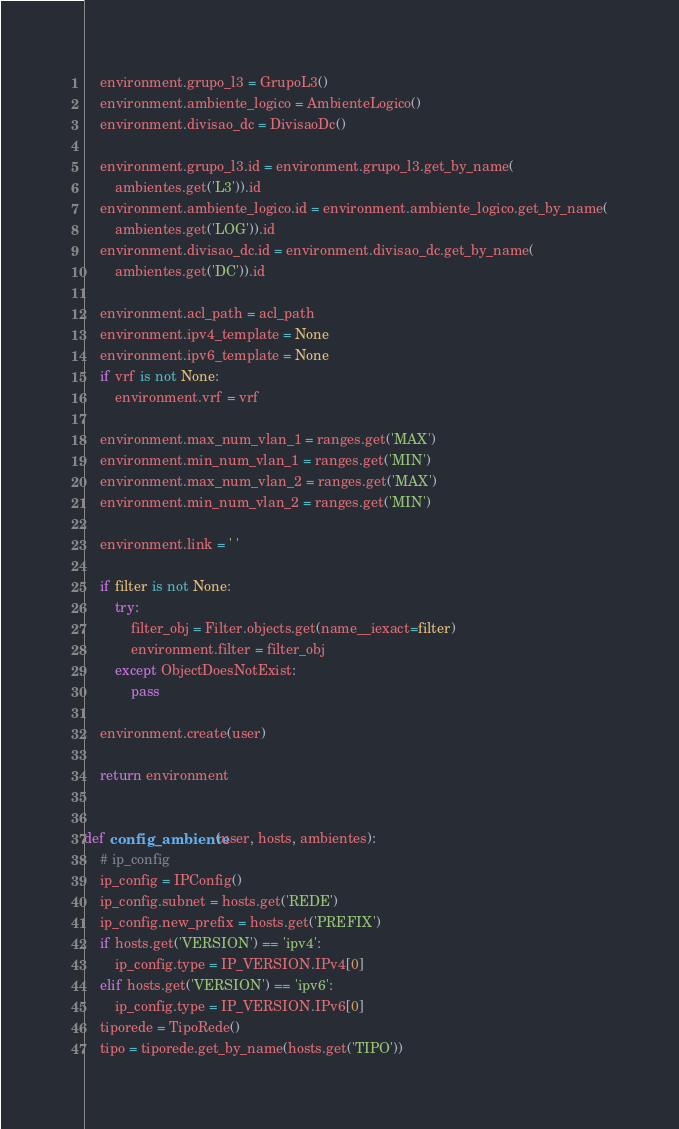Convert code to text. <code><loc_0><loc_0><loc_500><loc_500><_Python_>    environment.grupo_l3 = GrupoL3()
    environment.ambiente_logico = AmbienteLogico()
    environment.divisao_dc = DivisaoDc()

    environment.grupo_l3.id = environment.grupo_l3.get_by_name(
        ambientes.get('L3')).id
    environment.ambiente_logico.id = environment.ambiente_logico.get_by_name(
        ambientes.get('LOG')).id
    environment.divisao_dc.id = environment.divisao_dc.get_by_name(
        ambientes.get('DC')).id

    environment.acl_path = acl_path
    environment.ipv4_template = None
    environment.ipv6_template = None
    if vrf is not None:
        environment.vrf = vrf

    environment.max_num_vlan_1 = ranges.get('MAX')
    environment.min_num_vlan_1 = ranges.get('MIN')
    environment.max_num_vlan_2 = ranges.get('MAX')
    environment.min_num_vlan_2 = ranges.get('MIN')

    environment.link = ' '

    if filter is not None:
        try:
            filter_obj = Filter.objects.get(name__iexact=filter)
            environment.filter = filter_obj
        except ObjectDoesNotExist:
            pass

    environment.create(user)

    return environment


def config_ambiente(user, hosts, ambientes):
    # ip_config
    ip_config = IPConfig()
    ip_config.subnet = hosts.get('REDE')
    ip_config.new_prefix = hosts.get('PREFIX')
    if hosts.get('VERSION') == 'ipv4':
        ip_config.type = IP_VERSION.IPv4[0]
    elif hosts.get('VERSION') == 'ipv6':
        ip_config.type = IP_VERSION.IPv6[0]
    tiporede = TipoRede()
    tipo = tiporede.get_by_name(hosts.get('TIPO'))</code> 